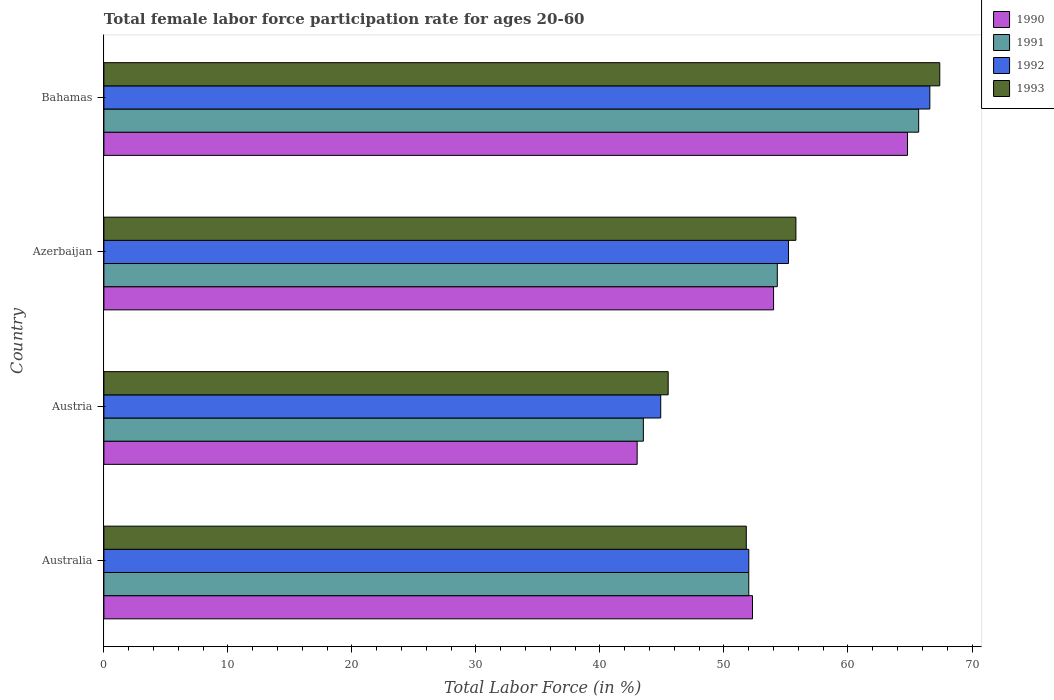How many groups of bars are there?
Your answer should be very brief. 4. How many bars are there on the 4th tick from the top?
Provide a short and direct response. 4. What is the label of the 3rd group of bars from the top?
Provide a short and direct response. Austria. In how many cases, is the number of bars for a given country not equal to the number of legend labels?
Keep it short and to the point. 0. What is the female labor force participation rate in 1991 in Bahamas?
Offer a terse response. 65.7. Across all countries, what is the maximum female labor force participation rate in 1993?
Provide a short and direct response. 67.4. Across all countries, what is the minimum female labor force participation rate in 1992?
Make the answer very short. 44.9. In which country was the female labor force participation rate in 1992 maximum?
Ensure brevity in your answer.  Bahamas. What is the total female labor force participation rate in 1990 in the graph?
Keep it short and to the point. 214.1. What is the difference between the female labor force participation rate in 1991 in Azerbaijan and that in Bahamas?
Your answer should be very brief. -11.4. What is the difference between the female labor force participation rate in 1992 in Azerbaijan and the female labor force participation rate in 1990 in Austria?
Offer a terse response. 12.2. What is the average female labor force participation rate in 1993 per country?
Keep it short and to the point. 55.12. What is the difference between the female labor force participation rate in 1992 and female labor force participation rate in 1990 in Bahamas?
Your answer should be compact. 1.8. In how many countries, is the female labor force participation rate in 1991 greater than 42 %?
Your answer should be very brief. 4. What is the ratio of the female labor force participation rate in 1991 in Austria to that in Bahamas?
Ensure brevity in your answer.  0.66. What is the difference between the highest and the second highest female labor force participation rate in 1992?
Ensure brevity in your answer.  11.4. What is the difference between the highest and the lowest female labor force participation rate in 1992?
Offer a terse response. 21.7. Is the sum of the female labor force participation rate in 1993 in Austria and Azerbaijan greater than the maximum female labor force participation rate in 1992 across all countries?
Your answer should be compact. Yes. How many bars are there?
Ensure brevity in your answer.  16. How many countries are there in the graph?
Keep it short and to the point. 4. What is the difference between two consecutive major ticks on the X-axis?
Give a very brief answer. 10. Does the graph contain grids?
Your answer should be very brief. No. Where does the legend appear in the graph?
Provide a short and direct response. Top right. How many legend labels are there?
Make the answer very short. 4. What is the title of the graph?
Offer a very short reply. Total female labor force participation rate for ages 20-60. What is the label or title of the X-axis?
Give a very brief answer. Total Labor Force (in %). What is the label or title of the Y-axis?
Offer a very short reply. Country. What is the Total Labor Force (in %) in 1990 in Australia?
Provide a short and direct response. 52.3. What is the Total Labor Force (in %) in 1991 in Australia?
Offer a very short reply. 52. What is the Total Labor Force (in %) in 1992 in Australia?
Provide a short and direct response. 52. What is the Total Labor Force (in %) of 1993 in Australia?
Your answer should be compact. 51.8. What is the Total Labor Force (in %) in 1990 in Austria?
Give a very brief answer. 43. What is the Total Labor Force (in %) of 1991 in Austria?
Provide a short and direct response. 43.5. What is the Total Labor Force (in %) of 1992 in Austria?
Provide a succinct answer. 44.9. What is the Total Labor Force (in %) of 1993 in Austria?
Your answer should be very brief. 45.5. What is the Total Labor Force (in %) of 1990 in Azerbaijan?
Provide a short and direct response. 54. What is the Total Labor Force (in %) in 1991 in Azerbaijan?
Give a very brief answer. 54.3. What is the Total Labor Force (in %) of 1992 in Azerbaijan?
Keep it short and to the point. 55.2. What is the Total Labor Force (in %) of 1993 in Azerbaijan?
Provide a succinct answer. 55.8. What is the Total Labor Force (in %) in 1990 in Bahamas?
Give a very brief answer. 64.8. What is the Total Labor Force (in %) in 1991 in Bahamas?
Provide a succinct answer. 65.7. What is the Total Labor Force (in %) in 1992 in Bahamas?
Make the answer very short. 66.6. What is the Total Labor Force (in %) in 1993 in Bahamas?
Make the answer very short. 67.4. Across all countries, what is the maximum Total Labor Force (in %) of 1990?
Offer a very short reply. 64.8. Across all countries, what is the maximum Total Labor Force (in %) of 1991?
Your answer should be compact. 65.7. Across all countries, what is the maximum Total Labor Force (in %) of 1992?
Your answer should be compact. 66.6. Across all countries, what is the maximum Total Labor Force (in %) of 1993?
Keep it short and to the point. 67.4. Across all countries, what is the minimum Total Labor Force (in %) of 1990?
Offer a very short reply. 43. Across all countries, what is the minimum Total Labor Force (in %) in 1991?
Your answer should be very brief. 43.5. Across all countries, what is the minimum Total Labor Force (in %) of 1992?
Provide a succinct answer. 44.9. Across all countries, what is the minimum Total Labor Force (in %) of 1993?
Make the answer very short. 45.5. What is the total Total Labor Force (in %) in 1990 in the graph?
Offer a very short reply. 214.1. What is the total Total Labor Force (in %) in 1991 in the graph?
Provide a short and direct response. 215.5. What is the total Total Labor Force (in %) of 1992 in the graph?
Provide a short and direct response. 218.7. What is the total Total Labor Force (in %) in 1993 in the graph?
Your response must be concise. 220.5. What is the difference between the Total Labor Force (in %) in 1990 in Australia and that in Austria?
Your answer should be very brief. 9.3. What is the difference between the Total Labor Force (in %) of 1993 in Australia and that in Austria?
Your response must be concise. 6.3. What is the difference between the Total Labor Force (in %) in 1990 in Australia and that in Azerbaijan?
Offer a terse response. -1.7. What is the difference between the Total Labor Force (in %) of 1991 in Australia and that in Bahamas?
Provide a short and direct response. -13.7. What is the difference between the Total Labor Force (in %) of 1992 in Australia and that in Bahamas?
Provide a short and direct response. -14.6. What is the difference between the Total Labor Force (in %) in 1993 in Australia and that in Bahamas?
Provide a succinct answer. -15.6. What is the difference between the Total Labor Force (in %) of 1990 in Austria and that in Azerbaijan?
Offer a terse response. -11. What is the difference between the Total Labor Force (in %) in 1991 in Austria and that in Azerbaijan?
Give a very brief answer. -10.8. What is the difference between the Total Labor Force (in %) of 1993 in Austria and that in Azerbaijan?
Offer a terse response. -10.3. What is the difference between the Total Labor Force (in %) in 1990 in Austria and that in Bahamas?
Your response must be concise. -21.8. What is the difference between the Total Labor Force (in %) of 1991 in Austria and that in Bahamas?
Keep it short and to the point. -22.2. What is the difference between the Total Labor Force (in %) in 1992 in Austria and that in Bahamas?
Keep it short and to the point. -21.7. What is the difference between the Total Labor Force (in %) of 1993 in Austria and that in Bahamas?
Provide a succinct answer. -21.9. What is the difference between the Total Labor Force (in %) of 1991 in Azerbaijan and that in Bahamas?
Provide a succinct answer. -11.4. What is the difference between the Total Labor Force (in %) in 1992 in Azerbaijan and that in Bahamas?
Keep it short and to the point. -11.4. What is the difference between the Total Labor Force (in %) of 1993 in Azerbaijan and that in Bahamas?
Offer a terse response. -11.6. What is the difference between the Total Labor Force (in %) in 1990 in Australia and the Total Labor Force (in %) in 1991 in Austria?
Offer a very short reply. 8.8. What is the difference between the Total Labor Force (in %) of 1990 in Australia and the Total Labor Force (in %) of 1992 in Austria?
Your answer should be very brief. 7.4. What is the difference between the Total Labor Force (in %) in 1991 in Australia and the Total Labor Force (in %) in 1993 in Austria?
Provide a short and direct response. 6.5. What is the difference between the Total Labor Force (in %) in 1992 in Australia and the Total Labor Force (in %) in 1993 in Austria?
Keep it short and to the point. 6.5. What is the difference between the Total Labor Force (in %) in 1990 in Australia and the Total Labor Force (in %) in 1991 in Azerbaijan?
Offer a terse response. -2. What is the difference between the Total Labor Force (in %) of 1991 in Australia and the Total Labor Force (in %) of 1992 in Azerbaijan?
Keep it short and to the point. -3.2. What is the difference between the Total Labor Force (in %) of 1991 in Australia and the Total Labor Force (in %) of 1993 in Azerbaijan?
Give a very brief answer. -3.8. What is the difference between the Total Labor Force (in %) in 1992 in Australia and the Total Labor Force (in %) in 1993 in Azerbaijan?
Your answer should be very brief. -3.8. What is the difference between the Total Labor Force (in %) in 1990 in Australia and the Total Labor Force (in %) in 1991 in Bahamas?
Offer a terse response. -13.4. What is the difference between the Total Labor Force (in %) of 1990 in Australia and the Total Labor Force (in %) of 1992 in Bahamas?
Make the answer very short. -14.3. What is the difference between the Total Labor Force (in %) of 1990 in Australia and the Total Labor Force (in %) of 1993 in Bahamas?
Provide a short and direct response. -15.1. What is the difference between the Total Labor Force (in %) of 1991 in Australia and the Total Labor Force (in %) of 1992 in Bahamas?
Your answer should be very brief. -14.6. What is the difference between the Total Labor Force (in %) in 1991 in Australia and the Total Labor Force (in %) in 1993 in Bahamas?
Offer a very short reply. -15.4. What is the difference between the Total Labor Force (in %) in 1992 in Australia and the Total Labor Force (in %) in 1993 in Bahamas?
Ensure brevity in your answer.  -15.4. What is the difference between the Total Labor Force (in %) in 1990 in Austria and the Total Labor Force (in %) in 1991 in Azerbaijan?
Give a very brief answer. -11.3. What is the difference between the Total Labor Force (in %) of 1990 in Austria and the Total Labor Force (in %) of 1993 in Azerbaijan?
Make the answer very short. -12.8. What is the difference between the Total Labor Force (in %) of 1991 in Austria and the Total Labor Force (in %) of 1992 in Azerbaijan?
Your response must be concise. -11.7. What is the difference between the Total Labor Force (in %) in 1992 in Austria and the Total Labor Force (in %) in 1993 in Azerbaijan?
Give a very brief answer. -10.9. What is the difference between the Total Labor Force (in %) in 1990 in Austria and the Total Labor Force (in %) in 1991 in Bahamas?
Give a very brief answer. -22.7. What is the difference between the Total Labor Force (in %) of 1990 in Austria and the Total Labor Force (in %) of 1992 in Bahamas?
Your response must be concise. -23.6. What is the difference between the Total Labor Force (in %) in 1990 in Austria and the Total Labor Force (in %) in 1993 in Bahamas?
Ensure brevity in your answer.  -24.4. What is the difference between the Total Labor Force (in %) of 1991 in Austria and the Total Labor Force (in %) of 1992 in Bahamas?
Ensure brevity in your answer.  -23.1. What is the difference between the Total Labor Force (in %) in 1991 in Austria and the Total Labor Force (in %) in 1993 in Bahamas?
Give a very brief answer. -23.9. What is the difference between the Total Labor Force (in %) in 1992 in Austria and the Total Labor Force (in %) in 1993 in Bahamas?
Offer a terse response. -22.5. What is the difference between the Total Labor Force (in %) of 1991 in Azerbaijan and the Total Labor Force (in %) of 1993 in Bahamas?
Make the answer very short. -13.1. What is the difference between the Total Labor Force (in %) in 1992 in Azerbaijan and the Total Labor Force (in %) in 1993 in Bahamas?
Your response must be concise. -12.2. What is the average Total Labor Force (in %) of 1990 per country?
Your answer should be compact. 53.52. What is the average Total Labor Force (in %) in 1991 per country?
Offer a very short reply. 53.88. What is the average Total Labor Force (in %) in 1992 per country?
Ensure brevity in your answer.  54.67. What is the average Total Labor Force (in %) of 1993 per country?
Ensure brevity in your answer.  55.12. What is the difference between the Total Labor Force (in %) of 1990 and Total Labor Force (in %) of 1991 in Australia?
Ensure brevity in your answer.  0.3. What is the difference between the Total Labor Force (in %) of 1990 and Total Labor Force (in %) of 1992 in Australia?
Ensure brevity in your answer.  0.3. What is the difference between the Total Labor Force (in %) of 1990 and Total Labor Force (in %) of 1993 in Australia?
Keep it short and to the point. 0.5. What is the difference between the Total Labor Force (in %) of 1992 and Total Labor Force (in %) of 1993 in Australia?
Your answer should be very brief. 0.2. What is the difference between the Total Labor Force (in %) in 1990 and Total Labor Force (in %) in 1992 in Austria?
Keep it short and to the point. -1.9. What is the difference between the Total Labor Force (in %) of 1990 and Total Labor Force (in %) of 1993 in Austria?
Your answer should be very brief. -2.5. What is the difference between the Total Labor Force (in %) of 1991 and Total Labor Force (in %) of 1992 in Austria?
Your answer should be compact. -1.4. What is the difference between the Total Labor Force (in %) in 1991 and Total Labor Force (in %) in 1993 in Austria?
Offer a terse response. -2. What is the difference between the Total Labor Force (in %) of 1990 and Total Labor Force (in %) of 1991 in Azerbaijan?
Offer a very short reply. -0.3. What is the difference between the Total Labor Force (in %) in 1990 and Total Labor Force (in %) in 1992 in Bahamas?
Provide a short and direct response. -1.8. What is the difference between the Total Labor Force (in %) of 1990 and Total Labor Force (in %) of 1993 in Bahamas?
Your answer should be compact. -2.6. What is the ratio of the Total Labor Force (in %) in 1990 in Australia to that in Austria?
Make the answer very short. 1.22. What is the ratio of the Total Labor Force (in %) in 1991 in Australia to that in Austria?
Provide a short and direct response. 1.2. What is the ratio of the Total Labor Force (in %) in 1992 in Australia to that in Austria?
Give a very brief answer. 1.16. What is the ratio of the Total Labor Force (in %) of 1993 in Australia to that in Austria?
Your answer should be very brief. 1.14. What is the ratio of the Total Labor Force (in %) in 1990 in Australia to that in Azerbaijan?
Give a very brief answer. 0.97. What is the ratio of the Total Labor Force (in %) in 1991 in Australia to that in Azerbaijan?
Your answer should be very brief. 0.96. What is the ratio of the Total Labor Force (in %) of 1992 in Australia to that in Azerbaijan?
Provide a succinct answer. 0.94. What is the ratio of the Total Labor Force (in %) in 1993 in Australia to that in Azerbaijan?
Offer a terse response. 0.93. What is the ratio of the Total Labor Force (in %) in 1990 in Australia to that in Bahamas?
Give a very brief answer. 0.81. What is the ratio of the Total Labor Force (in %) in 1991 in Australia to that in Bahamas?
Offer a very short reply. 0.79. What is the ratio of the Total Labor Force (in %) in 1992 in Australia to that in Bahamas?
Offer a terse response. 0.78. What is the ratio of the Total Labor Force (in %) in 1993 in Australia to that in Bahamas?
Offer a terse response. 0.77. What is the ratio of the Total Labor Force (in %) of 1990 in Austria to that in Azerbaijan?
Your response must be concise. 0.8. What is the ratio of the Total Labor Force (in %) in 1991 in Austria to that in Azerbaijan?
Make the answer very short. 0.8. What is the ratio of the Total Labor Force (in %) in 1992 in Austria to that in Azerbaijan?
Your response must be concise. 0.81. What is the ratio of the Total Labor Force (in %) in 1993 in Austria to that in Azerbaijan?
Provide a succinct answer. 0.82. What is the ratio of the Total Labor Force (in %) in 1990 in Austria to that in Bahamas?
Provide a succinct answer. 0.66. What is the ratio of the Total Labor Force (in %) in 1991 in Austria to that in Bahamas?
Keep it short and to the point. 0.66. What is the ratio of the Total Labor Force (in %) in 1992 in Austria to that in Bahamas?
Your response must be concise. 0.67. What is the ratio of the Total Labor Force (in %) of 1993 in Austria to that in Bahamas?
Give a very brief answer. 0.68. What is the ratio of the Total Labor Force (in %) of 1990 in Azerbaijan to that in Bahamas?
Your response must be concise. 0.83. What is the ratio of the Total Labor Force (in %) in 1991 in Azerbaijan to that in Bahamas?
Give a very brief answer. 0.83. What is the ratio of the Total Labor Force (in %) of 1992 in Azerbaijan to that in Bahamas?
Offer a terse response. 0.83. What is the ratio of the Total Labor Force (in %) in 1993 in Azerbaijan to that in Bahamas?
Your answer should be very brief. 0.83. What is the difference between the highest and the second highest Total Labor Force (in %) in 1991?
Your answer should be compact. 11.4. What is the difference between the highest and the second highest Total Labor Force (in %) of 1993?
Make the answer very short. 11.6. What is the difference between the highest and the lowest Total Labor Force (in %) in 1990?
Offer a very short reply. 21.8. What is the difference between the highest and the lowest Total Labor Force (in %) of 1991?
Your answer should be compact. 22.2. What is the difference between the highest and the lowest Total Labor Force (in %) in 1992?
Give a very brief answer. 21.7. What is the difference between the highest and the lowest Total Labor Force (in %) of 1993?
Your answer should be very brief. 21.9. 